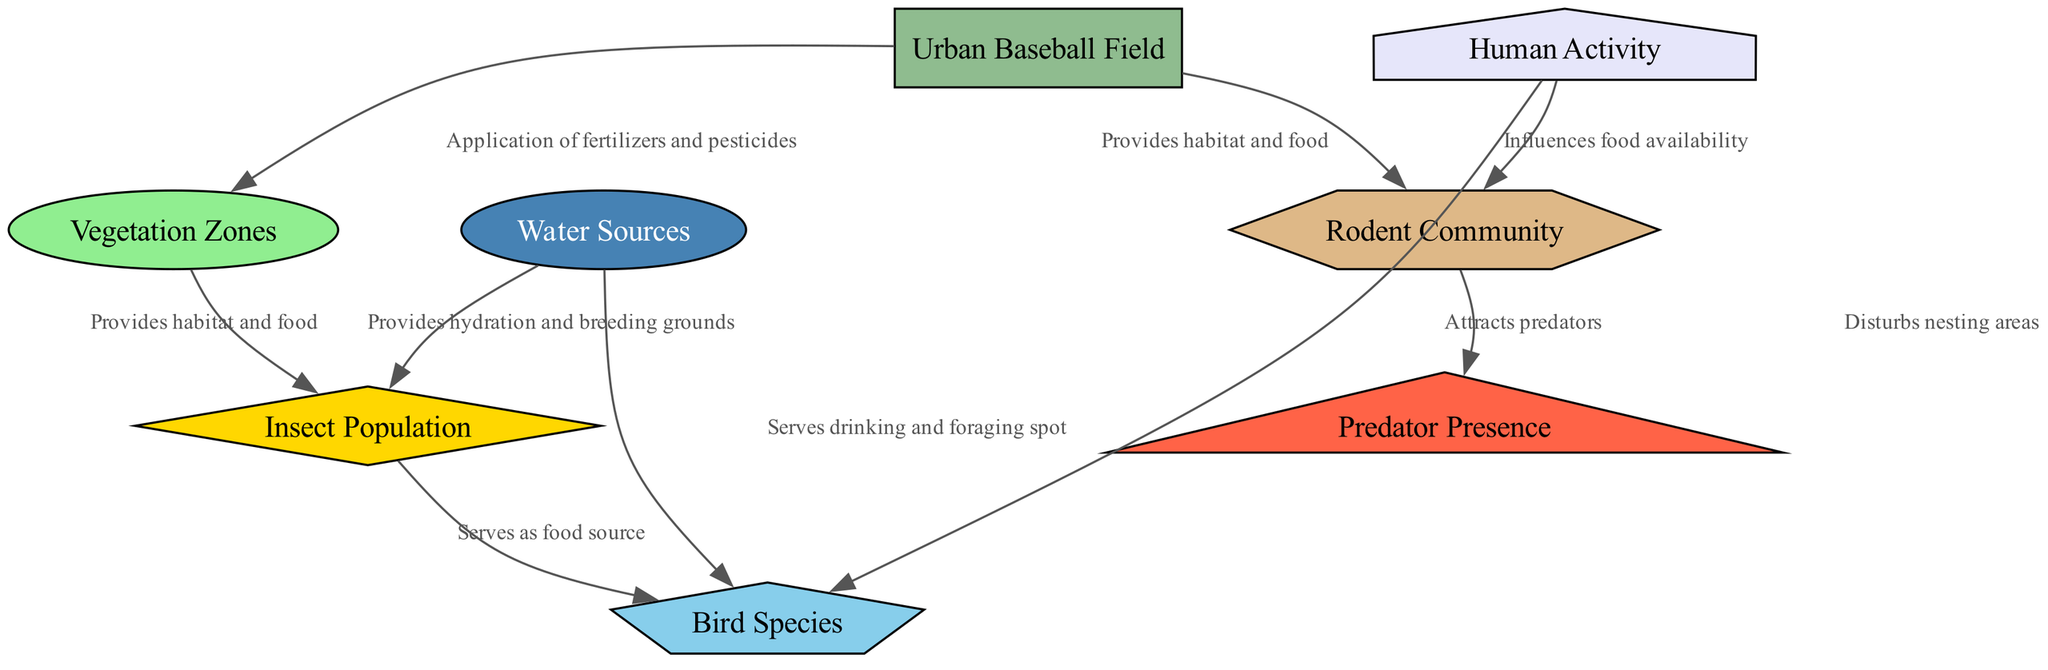What is the primary human impact on bird species? The diagram indicates that human activity disturbs nesting areas of bird species. This means that when humans are active around the baseball field, it can potentially disturb the birds that are attempting to nest in that area.
Answer: Disturbs nesting areas How many nodes are present in the diagram? The diagram lists a total of 8 distinct nodes including the urban baseball field, vegetation zones, insect population, bird species, rodent community, predator presence, human activity, and water sources.
Answer: 8 What do vegetation zones provide for the insect population? According to the diagram, vegetation zones provide habitat and food for the insect population. Thus, the presence and health of vegetation are crucial for the survival and proliferation of insects.
Answer: Habitat and food Which factor attracts predators according to the diagram? The diagram shows that the rodent community attracts predators. This implies that wherever there are rodents available as a food source, predators are likely to be present as well.
Answer: Rodent community How do water sources benefit bird species? Water sources serve as a drinking and foraging spot for bird species. This indicates that water availability in the environment is essential for bird survival and feeding behavior.
Answer: Serves drinking and foraging spot What role do water sources play in the insect population dynamics? The diagram indicates that water sources provide hydration and breeding grounds for the insect population. This means that the availability of water is critical for both the survival and reproduction of insects.
Answer: Provides hydration and breeding grounds What is the relationship between the urban baseball field and vegetation zones? The urban baseball field directly affects vegetation zones through the application of fertilizers and pesticides, which can alter the growth and health of the plants in these zones.
Answer: Application of fertilizers and pesticides How does human activity influence the rodent community? The diagram shows that human activity influences food availability for the rodent community. This suggests that activities such as littering or feeding can affect how many rodents can survive and thrive in the area.
Answer: Influences food availability 